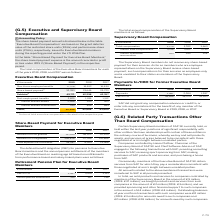According to Sap Ag's financial document, What was the total amount of Executive Board Compensation in 2019? According to the financial document, 52,596 (in thousands). The relevant text states: "Total 1) 52,596 43,404 43,669..." Also, What does the subtotal amount of compensation relate to? Portion of total executive compensation allocated to the respective year. The document states: "1) Portion of total executive compensation allocated to the respective year..." Also, In which years was the total compensation for Executive Board Members calculated? The document contains multiple relevant values: 2019, 2018, 2017. From the document: "€ thousands 2019 2018 2017 € thousands 2019 2018 2017 € thousands 2019 2018 2017..." Additionally, In which year was the amount Thereof defined-contribution largest? According to the financial document, 2017. The relevant text states: "€ thousands 2019 2018 2017..." Also, can you calculate: What was the change in Thereof defined-contribution in 2019 from 2018? Based on the calculation: 769-856, the result is -87 (in thousands). This is based on the information: "Thereof defined-contribution 769 856 889 Thereof defined-contribution 769 856 889..." The key data points involved are: 769, 856. Also, can you calculate: What was the percentage change in Thereof defined-contribution in 2019 from 2018? To answer this question, I need to perform calculations using the financial data. The calculation is: (769-856)/856, which equals -10.16 (percentage). This is based on the information: "Thereof defined-contribution 769 856 889 Thereof defined-contribution 769 856 889..." The key data points involved are: 769, 856. 